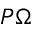Convert formula to latex. <formula><loc_0><loc_0><loc_500><loc_500>P \Omega</formula> 